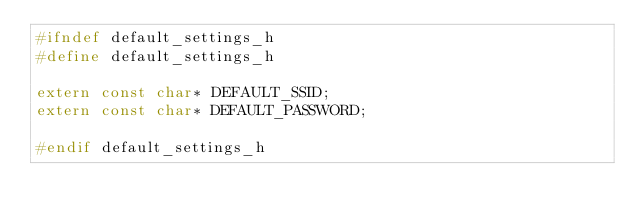Convert code to text. <code><loc_0><loc_0><loc_500><loc_500><_C_>#ifndef default_settings_h
#define default_settings_h

extern const char* DEFAULT_SSID;
extern const char* DEFAULT_PASSWORD;

#endif default_settings_h</code> 